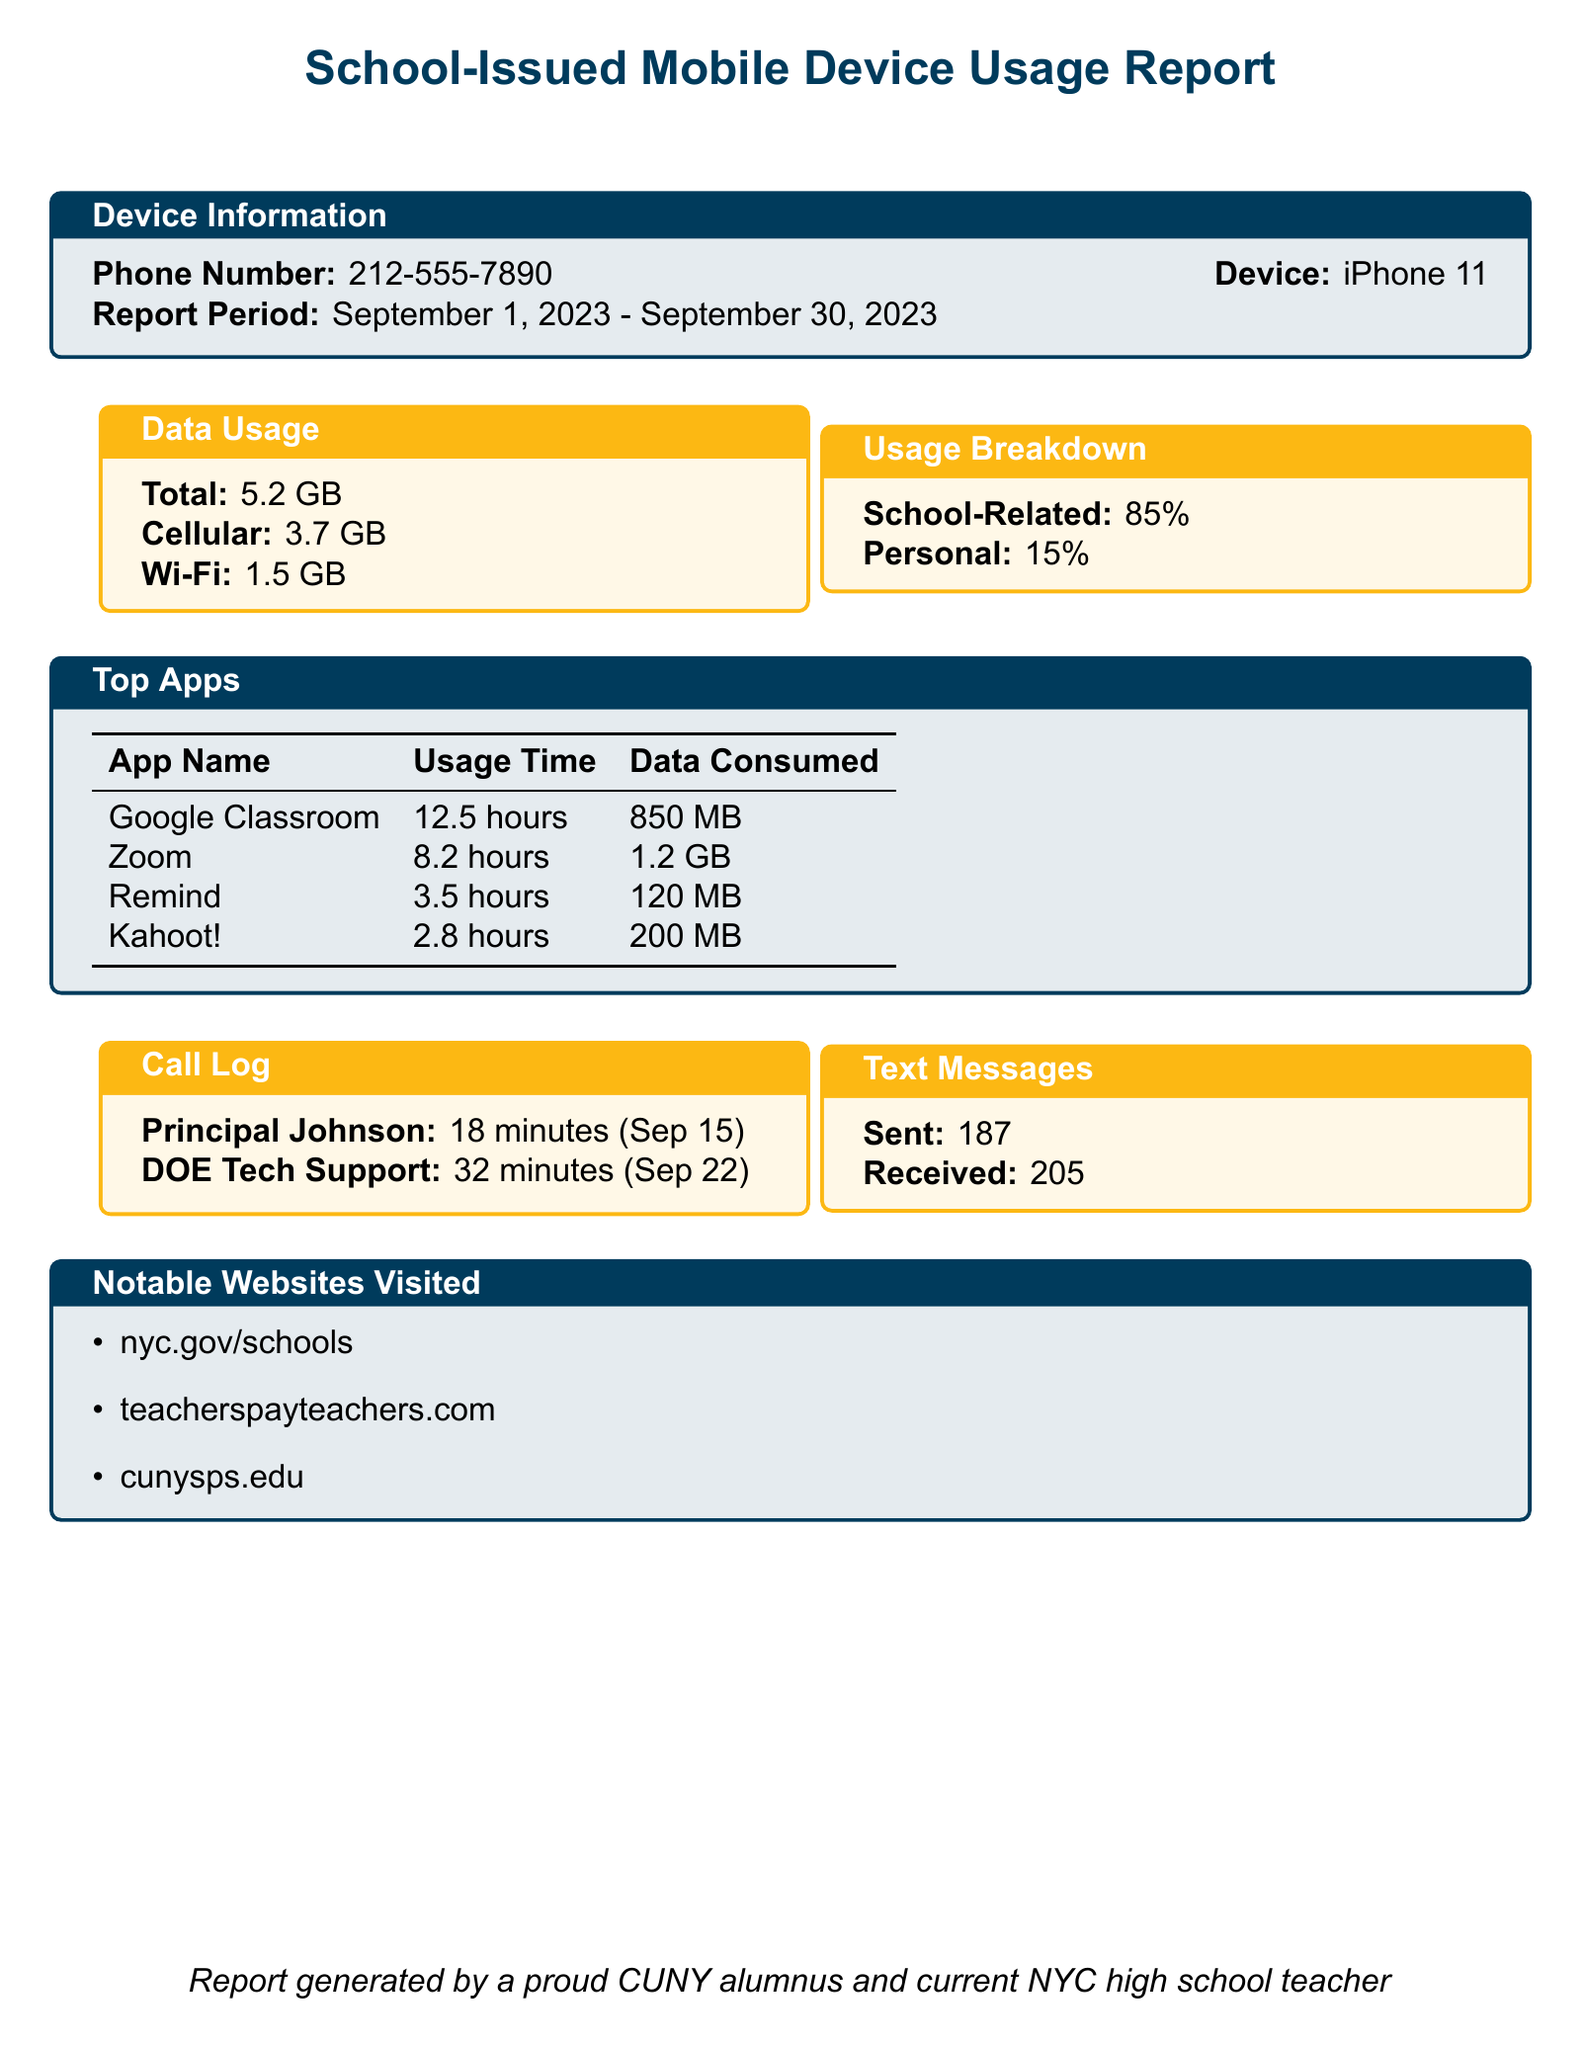What is the phone number of the device? The phone number is found in the Device Information section of the document.
Answer: 212-555-7890 What is the total data usage for the report period? The total data usage is provided in the Data Usage section of the document.
Answer: 5.2 GB What percentage of usage was school-related? The percentage of school-related usage is specified in the Usage Breakdown section.
Answer: 85% How many hours were spent using Google Classroom? The usage time for Google Classroom is listed in the Top Apps table.
Answer: 12.5 hours Who was contacted the most via phone? The call log shows the names of the people contacted, with the principal having the most minutes.
Answer: Principal Johnson How much data did Zoom consume? The data consumed by Zoom is provided in the Top Apps table.
Answer: 1.2 GB What was the date of the call to DOE Tech Support? The date is noted next to the duration of the call in the Call Log section.
Answer: Sep 22 How many text messages were received? The number of received messages is indicated in the Text Messages section.
Answer: 205 What is one notable website visited? The notable websites are listed in the Notable Websites Visited section.
Answer: nyc.gov/schools 